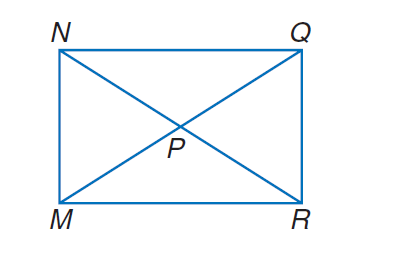Answer the mathemtical geometry problem and directly provide the correct option letter.
Question: M N Q R is a rectangle. If N R = 2 x + 10 and N P = 2 x - 30, find M P.
Choices: A: 10 B: 20 C: 30 D: 40 D 